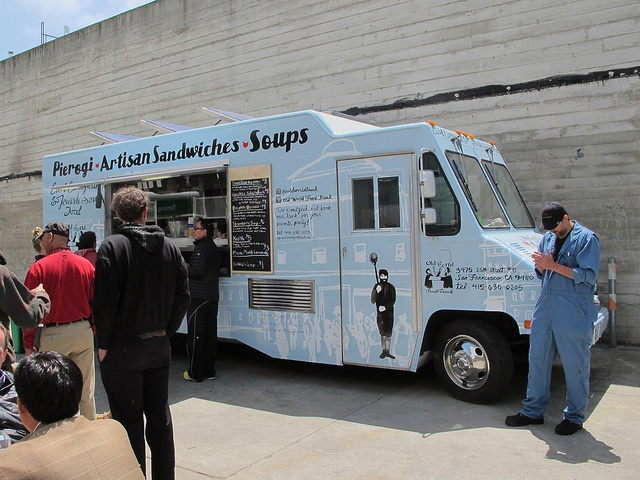Describe the objects in this image and their specific colors. I can see truck in lightblue, darkgray, black, and gray tones, people in lightblue, black, gray, and darkgray tones, people in lightblue, gray, blue, and black tones, people in lightblue, tan, black, and gray tones, and people in lightblue, maroon, gray, and black tones in this image. 